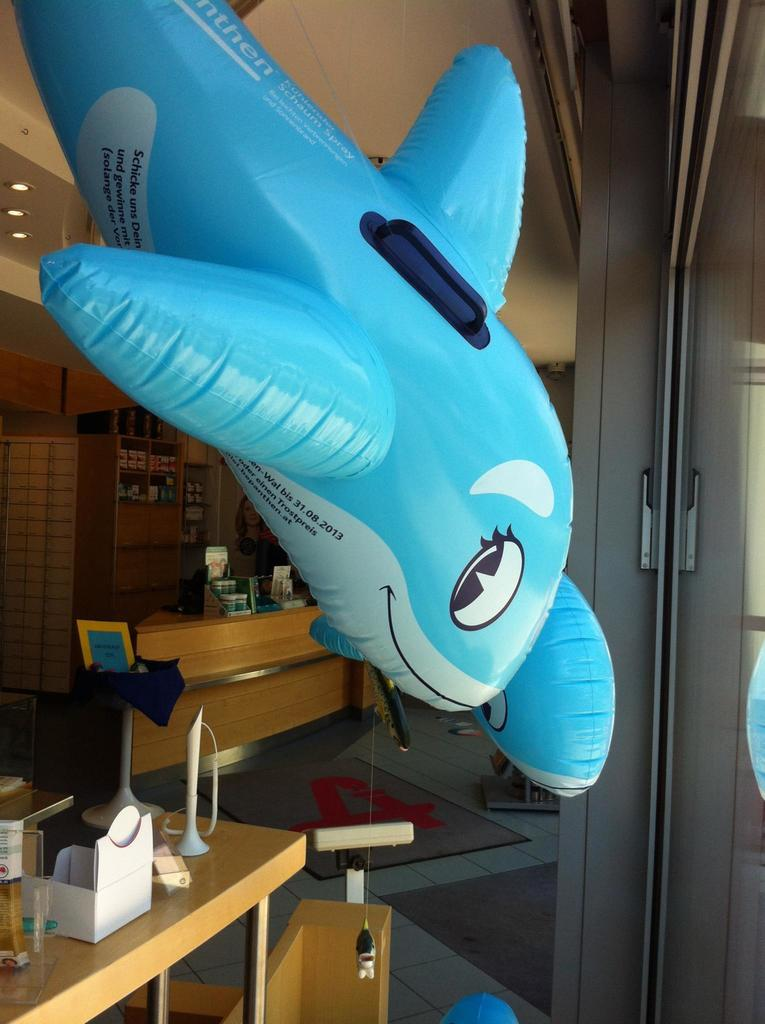Provide a one-sentence caption for the provided image. A blue inflatable whale with the date 31/08/20 on its white belly. 